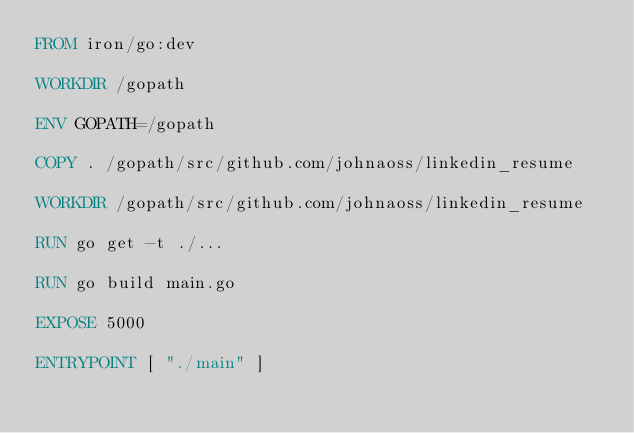Convert code to text. <code><loc_0><loc_0><loc_500><loc_500><_Dockerfile_>FROM iron/go:dev

WORKDIR /gopath

ENV GOPATH=/gopath

COPY . /gopath/src/github.com/johnaoss/linkedin_resume

WORKDIR /gopath/src/github.com/johnaoss/linkedin_resume

RUN go get -t ./...

RUN go build main.go

EXPOSE 5000

ENTRYPOINT [ "./main" ]</code> 